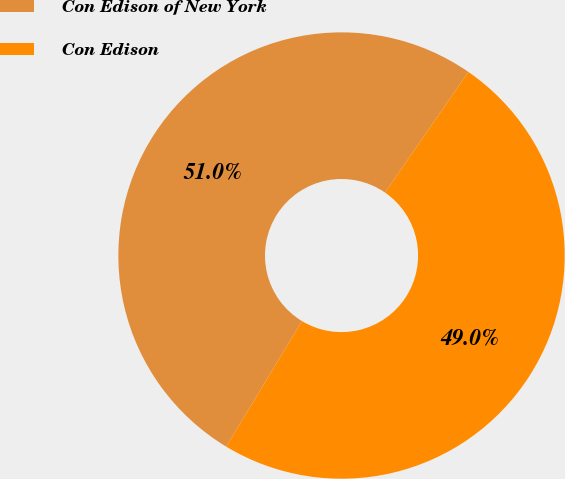Convert chart to OTSL. <chart><loc_0><loc_0><loc_500><loc_500><pie_chart><fcel>Con Edison of New York<fcel>Con Edison<nl><fcel>50.97%<fcel>49.03%<nl></chart> 